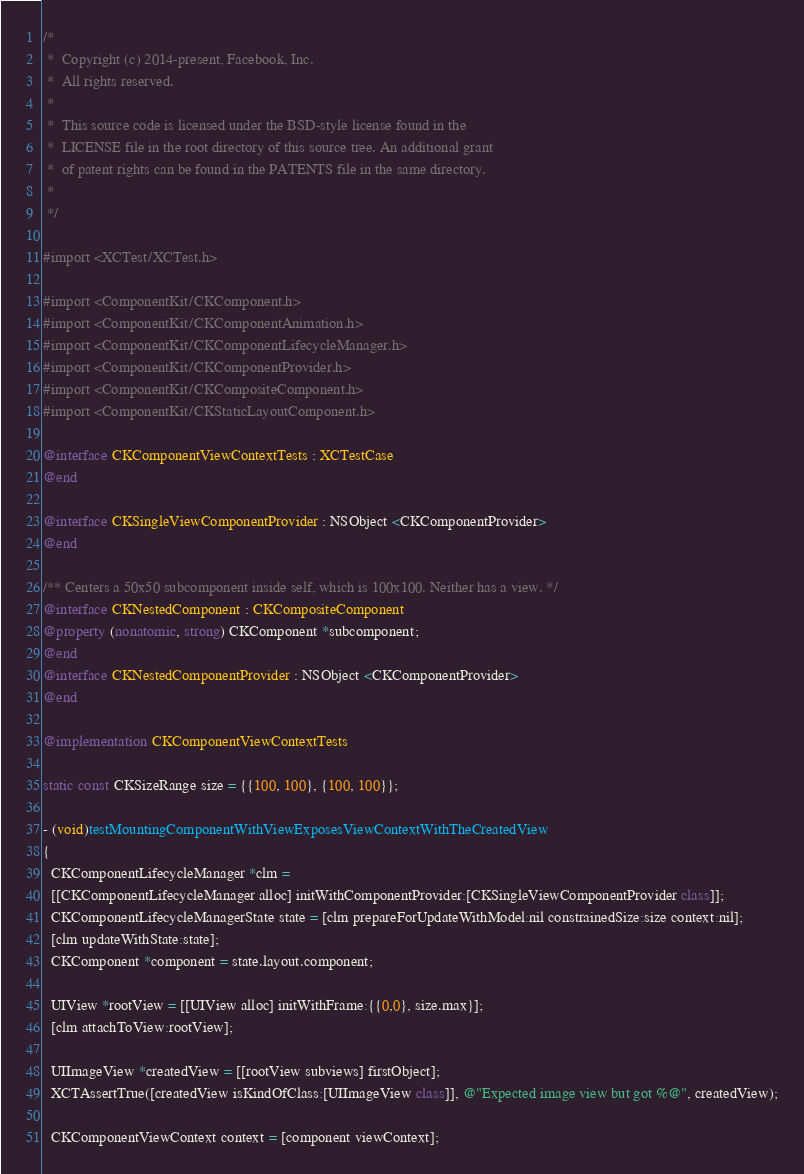Convert code to text. <code><loc_0><loc_0><loc_500><loc_500><_ObjectiveC_>/*
 *  Copyright (c) 2014-present, Facebook, Inc.
 *  All rights reserved.
 *
 *  This source code is licensed under the BSD-style license found in the
 *  LICENSE file in the root directory of this source tree. An additional grant
 *  of patent rights can be found in the PATENTS file in the same directory.
 *
 */

#import <XCTest/XCTest.h>

#import <ComponentKit/CKComponent.h>
#import <ComponentKit/CKComponentAnimation.h>
#import <ComponentKit/CKComponentLifecycleManager.h>
#import <ComponentKit/CKComponentProvider.h>
#import <ComponentKit/CKCompositeComponent.h>
#import <ComponentKit/CKStaticLayoutComponent.h>

@interface CKComponentViewContextTests : XCTestCase
@end

@interface CKSingleViewComponentProvider : NSObject <CKComponentProvider>
@end

/** Centers a 50x50 subcomponent inside self, which is 100x100. Neither has a view. */
@interface CKNestedComponent : CKCompositeComponent
@property (nonatomic, strong) CKComponent *subcomponent;
@end
@interface CKNestedComponentProvider : NSObject <CKComponentProvider>
@end

@implementation CKComponentViewContextTests

static const CKSizeRange size = {{100, 100}, {100, 100}};

- (void)testMountingComponentWithViewExposesViewContextWithTheCreatedView
{
  CKComponentLifecycleManager *clm =
  [[CKComponentLifecycleManager alloc] initWithComponentProvider:[CKSingleViewComponentProvider class]];
  CKComponentLifecycleManagerState state = [clm prepareForUpdateWithModel:nil constrainedSize:size context:nil];
  [clm updateWithState:state];
  CKComponent *component = state.layout.component;

  UIView *rootView = [[UIView alloc] initWithFrame:{{0,0}, size.max}];
  [clm attachToView:rootView];

  UIImageView *createdView = [[rootView subviews] firstObject];
  XCTAssertTrue([createdView isKindOfClass:[UIImageView class]], @"Expected image view but got %@", createdView);

  CKComponentViewContext context = [component viewContext];</code> 